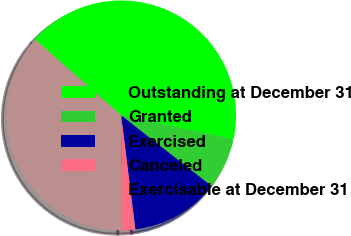Convert chart to OTSL. <chart><loc_0><loc_0><loc_500><loc_500><pie_chart><fcel>Outstanding at December 31<fcel>Granted<fcel>Exercised<fcel>Canceled<fcel>Exercisable at December 31<nl><fcel>41.87%<fcel>7.19%<fcel>12.47%<fcel>1.9%<fcel>36.58%<nl></chart> 